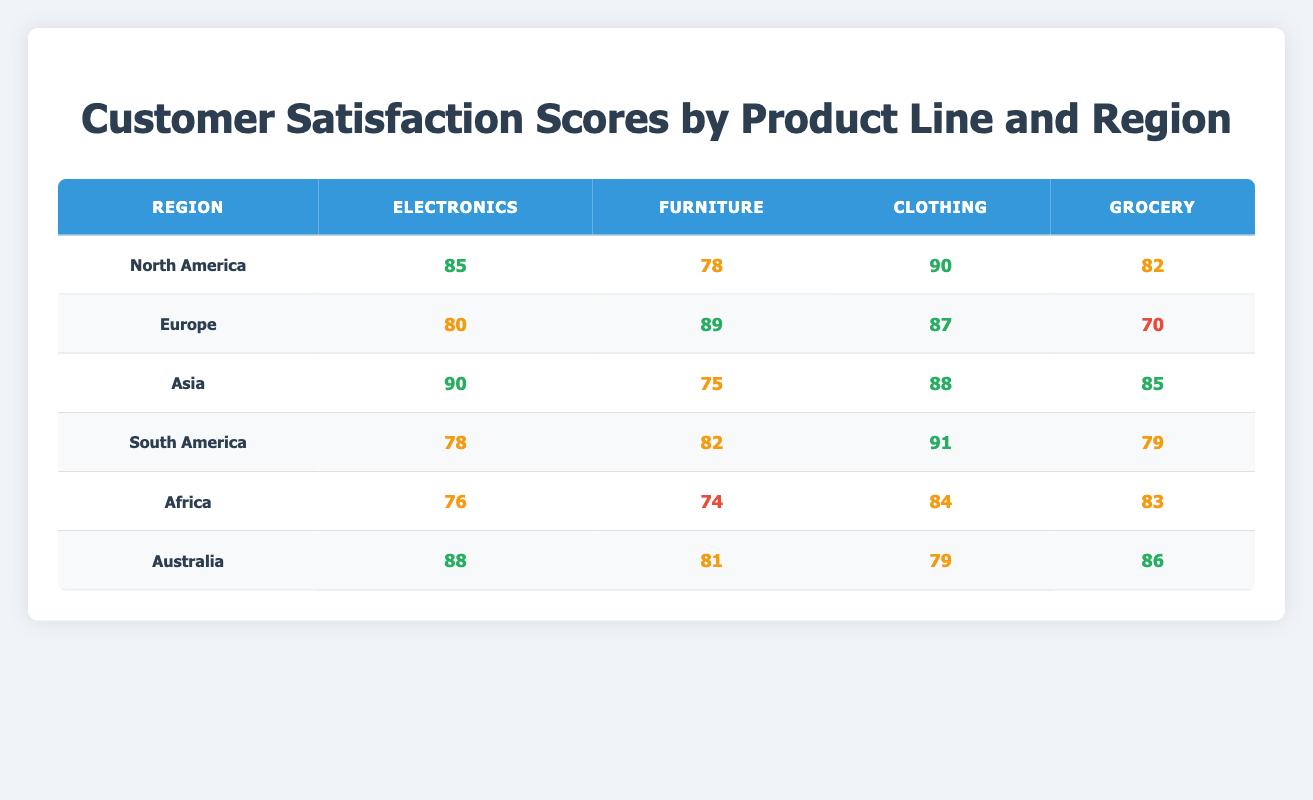What is the customer satisfaction score for Electronics in Asia? The score for Electronics in Asia can be found in the corresponding row under the Electronics column for the Asia region, which states 90.
Answer: 90 Which region has the highest Clothing satisfaction score? By comparing the Clothing scores across all regions, South America has the highest score at 91.
Answer: South America What is the average satisfaction score for Grocery across all regions? The Grocery scores are 82 (North America), 70 (Europe), 85 (Asia), 79 (South America), 83 (Africa), and 86 (Australia). The total is 485, and there are 6 regions, so the average is 485/6 ≈ 80.83.
Answer: 80.83 Is the satisfaction score for Furniture in Europe higher than in Asia? The Furniture score for Europe is 89, while for Asia, it is 75. Since 89 is greater than 75, the statement is true.
Answer: Yes What is the difference between the highest and lowest Electronics scores in the table? The highest score for Electronics is 90 (Asia) and the lowest is 76 (Africa). The difference is 90 - 76 = 14.
Answer: 14 Which product line has the lowest average satisfaction score across all regions? First, calculate the average for each product line: Electronics = 85.33, Furniture = 79.17, Clothing = 85.00, Grocery = 80.83. The lowest average is for Furniture.
Answer: Furniture Do all regions score above 75 in Clothing? The Clothing scores are 90 (North America), 87 (Europe), 88 (Asia), 91 (South America), 84 (Africa), and 79 (Australia). The lowest score is 79, which is above 75. Hence, the statement is true.
Answer: Yes Which region's Electronics score is closest to the average Electronics score of all regions? The average score for Electronics is (85 + 80 + 90 + 78 + 76 + 88) / 6 = 82.17. The closest score is from Europe at 80 and South America at 78.
Answer: Europe and South America What is the total customer satisfaction score for North America across all product lines? Adding the scores in North America together: 85 (Electronics) + 78 (Furniture) + 90 (Clothing) + 82 (Grocery) = 335.
Answer: 335 Which product line has the highest score in Australia? In Australia, the scores are: 88 (Electronics), 81 (Furniture), 79 (Clothing), and 86 (Grocery). The highest score is 88 for Electronics.
Answer: Electronics 